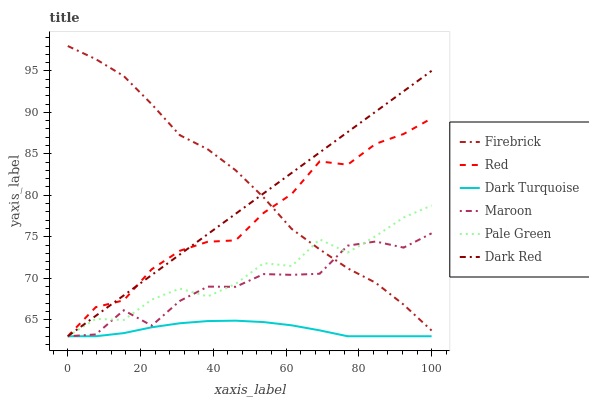Does Dark Turquoise have the minimum area under the curve?
Answer yes or no. Yes. Does Firebrick have the maximum area under the curve?
Answer yes or no. Yes. Does Maroon have the minimum area under the curve?
Answer yes or no. No. Does Maroon have the maximum area under the curve?
Answer yes or no. No. Is Dark Red the smoothest?
Answer yes or no. Yes. Is Maroon the roughest?
Answer yes or no. Yes. Is Firebrick the smoothest?
Answer yes or no. No. Is Firebrick the roughest?
Answer yes or no. No. Does Dark Turquoise have the lowest value?
Answer yes or no. Yes. Does Firebrick have the lowest value?
Answer yes or no. No. Does Firebrick have the highest value?
Answer yes or no. Yes. Does Maroon have the highest value?
Answer yes or no. No. Is Dark Turquoise less than Firebrick?
Answer yes or no. Yes. Is Firebrick greater than Dark Turquoise?
Answer yes or no. Yes. Does Maroon intersect Red?
Answer yes or no. Yes. Is Maroon less than Red?
Answer yes or no. No. Is Maroon greater than Red?
Answer yes or no. No. Does Dark Turquoise intersect Firebrick?
Answer yes or no. No. 